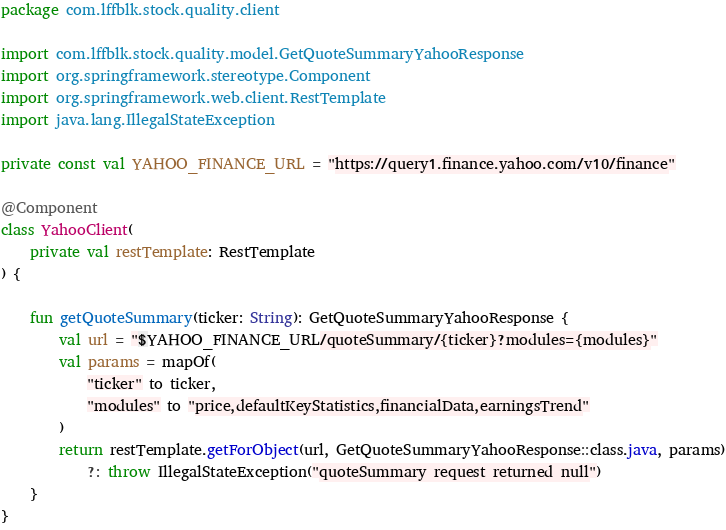<code> <loc_0><loc_0><loc_500><loc_500><_Kotlin_>package com.lffblk.stock.quality.client

import com.lffblk.stock.quality.model.GetQuoteSummaryYahooResponse
import org.springframework.stereotype.Component
import org.springframework.web.client.RestTemplate
import java.lang.IllegalStateException

private const val YAHOO_FINANCE_URL = "https://query1.finance.yahoo.com/v10/finance"

@Component
class YahooClient(
    private val restTemplate: RestTemplate
) {

    fun getQuoteSummary(ticker: String): GetQuoteSummaryYahooResponse {
        val url = "$YAHOO_FINANCE_URL/quoteSummary/{ticker}?modules={modules}"
        val params = mapOf(
            "ticker" to ticker,
            "modules" to "price,defaultKeyStatistics,financialData,earningsTrend"
        )
        return restTemplate.getForObject(url, GetQuoteSummaryYahooResponse::class.java, params)
            ?: throw IllegalStateException("quoteSummary request returned null")
    }
}</code> 